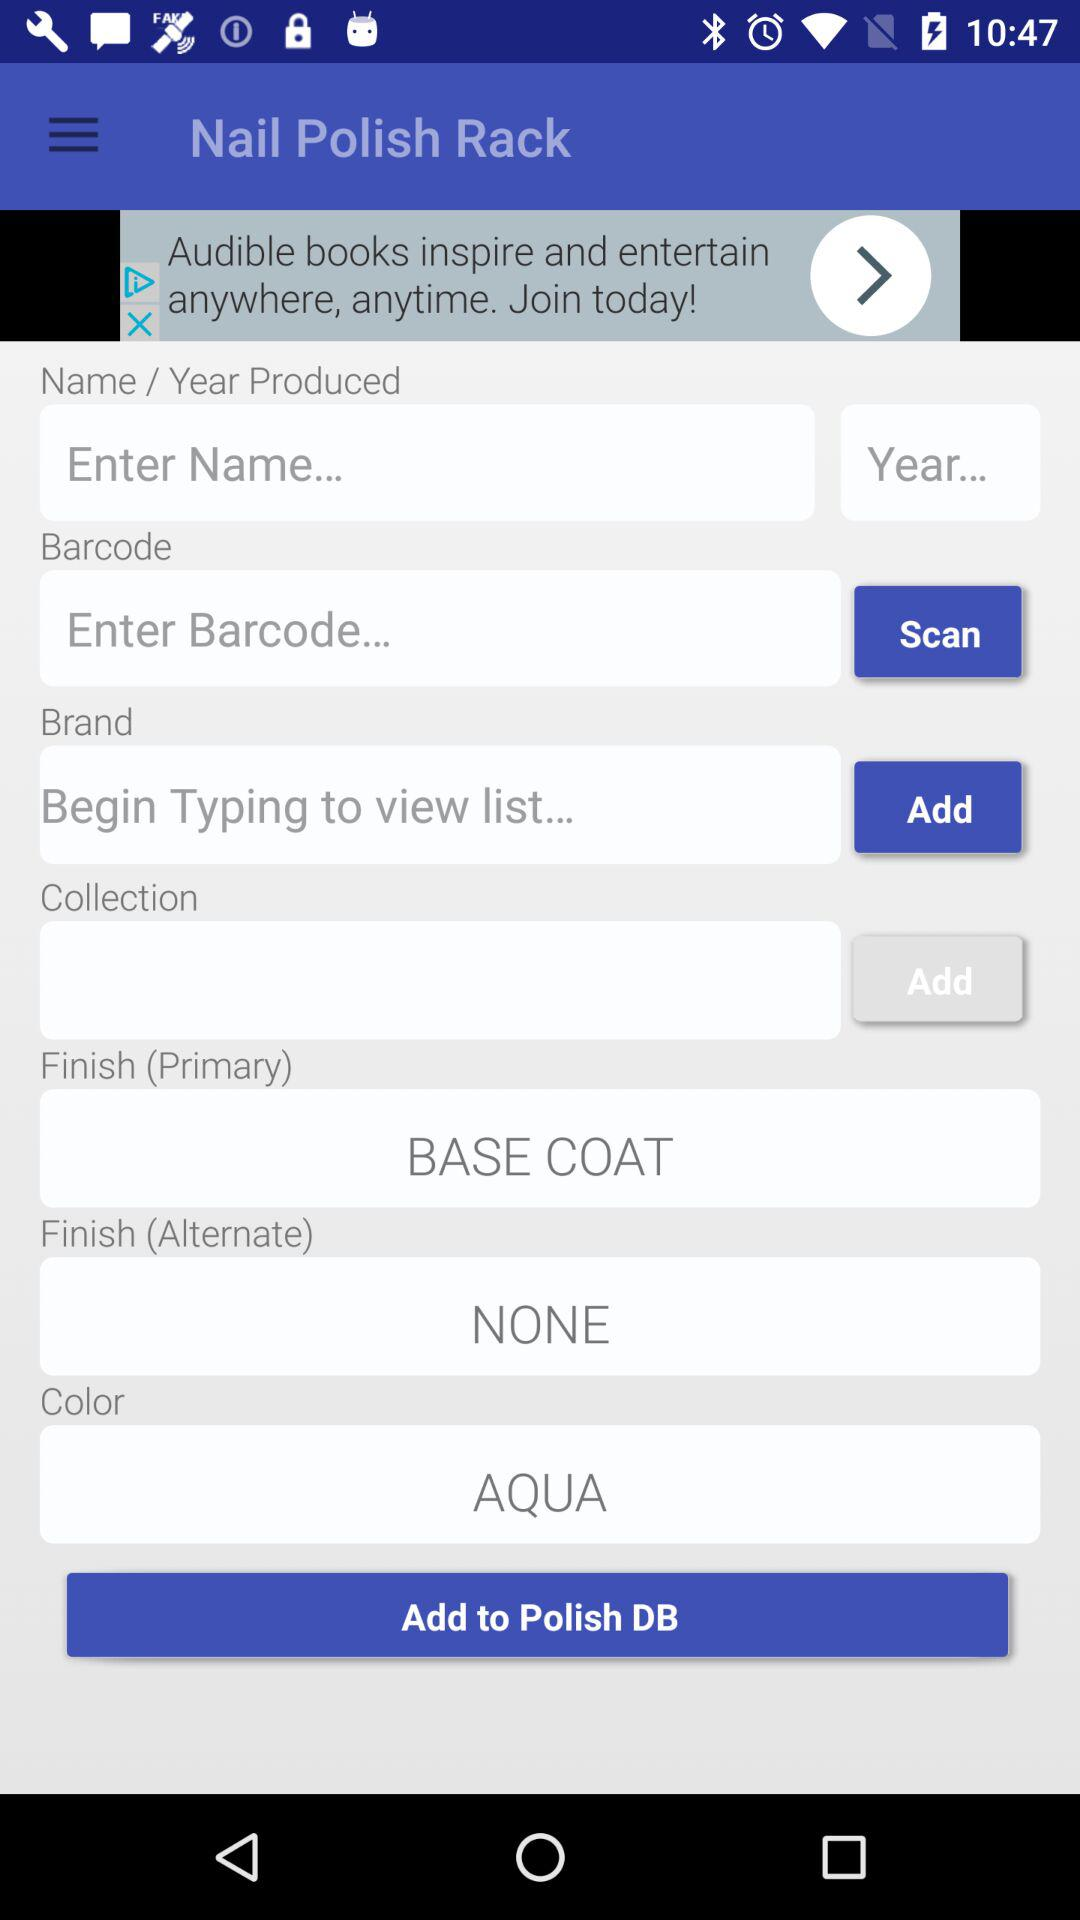What is the color? The color is aqua. 